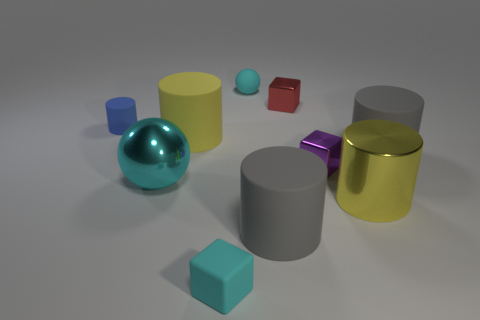There is a small cylinder; is it the same color as the sphere that is in front of the tiny sphere? The small cylinder has a different color compared to the large teal sphere, which is positioned in front of the smaller, blue sphere. The cylinder appears to be yellow, thereby contrasting with the teal sphere. 